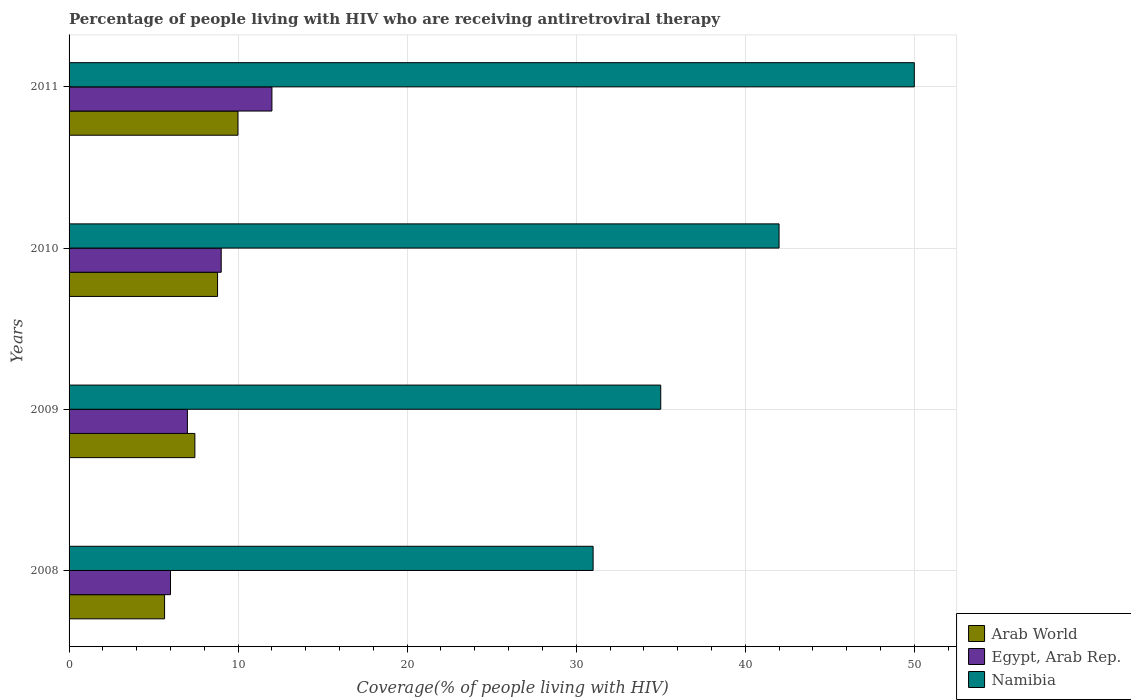In how many cases, is the number of bars for a given year not equal to the number of legend labels?
Ensure brevity in your answer.  0. What is the percentage of the HIV infected people who are receiving antiretroviral therapy in Egypt, Arab Rep. in 2010?
Keep it short and to the point. 9. Across all years, what is the maximum percentage of the HIV infected people who are receiving antiretroviral therapy in Arab World?
Make the answer very short. 9.99. What is the total percentage of the HIV infected people who are receiving antiretroviral therapy in Arab World in the graph?
Ensure brevity in your answer.  31.87. What is the difference between the percentage of the HIV infected people who are receiving antiretroviral therapy in Arab World in 2008 and that in 2011?
Make the answer very short. -4.34. What is the difference between the percentage of the HIV infected people who are receiving antiretroviral therapy in Namibia in 2010 and the percentage of the HIV infected people who are receiving antiretroviral therapy in Egypt, Arab Rep. in 2009?
Your response must be concise. 35. What is the average percentage of the HIV infected people who are receiving antiretroviral therapy in Namibia per year?
Make the answer very short. 39.5. In the year 2009, what is the difference between the percentage of the HIV infected people who are receiving antiretroviral therapy in Egypt, Arab Rep. and percentage of the HIV infected people who are receiving antiretroviral therapy in Namibia?
Ensure brevity in your answer.  -28. In how many years, is the percentage of the HIV infected people who are receiving antiretroviral therapy in Arab World greater than 34 %?
Keep it short and to the point. 0. What is the ratio of the percentage of the HIV infected people who are receiving antiretroviral therapy in Egypt, Arab Rep. in 2009 to that in 2011?
Provide a short and direct response. 0.58. Is the percentage of the HIV infected people who are receiving antiretroviral therapy in Namibia in 2008 less than that in 2010?
Your response must be concise. Yes. What is the difference between the highest and the lowest percentage of the HIV infected people who are receiving antiretroviral therapy in Namibia?
Provide a short and direct response. 19. In how many years, is the percentage of the HIV infected people who are receiving antiretroviral therapy in Arab World greater than the average percentage of the HIV infected people who are receiving antiretroviral therapy in Arab World taken over all years?
Provide a succinct answer. 2. Is the sum of the percentage of the HIV infected people who are receiving antiretroviral therapy in Egypt, Arab Rep. in 2008 and 2009 greater than the maximum percentage of the HIV infected people who are receiving antiretroviral therapy in Arab World across all years?
Your answer should be very brief. Yes. What does the 2nd bar from the top in 2010 represents?
Ensure brevity in your answer.  Egypt, Arab Rep. What does the 1st bar from the bottom in 2009 represents?
Your answer should be compact. Arab World. How many years are there in the graph?
Your response must be concise. 4. What is the difference between two consecutive major ticks on the X-axis?
Your answer should be compact. 10. Does the graph contain grids?
Your answer should be very brief. Yes. Where does the legend appear in the graph?
Give a very brief answer. Bottom right. What is the title of the graph?
Offer a very short reply. Percentage of people living with HIV who are receiving antiretroviral therapy. What is the label or title of the X-axis?
Keep it short and to the point. Coverage(% of people living with HIV). What is the label or title of the Y-axis?
Provide a succinct answer. Years. What is the Coverage(% of people living with HIV) in Arab World in 2008?
Provide a succinct answer. 5.65. What is the Coverage(% of people living with HIV) of Arab World in 2009?
Give a very brief answer. 7.44. What is the Coverage(% of people living with HIV) in Namibia in 2009?
Provide a short and direct response. 35. What is the Coverage(% of people living with HIV) in Arab World in 2010?
Your answer should be compact. 8.78. What is the Coverage(% of people living with HIV) in Arab World in 2011?
Keep it short and to the point. 9.99. Across all years, what is the maximum Coverage(% of people living with HIV) in Arab World?
Provide a short and direct response. 9.99. Across all years, what is the maximum Coverage(% of people living with HIV) in Namibia?
Make the answer very short. 50. Across all years, what is the minimum Coverage(% of people living with HIV) of Arab World?
Provide a succinct answer. 5.65. Across all years, what is the minimum Coverage(% of people living with HIV) of Egypt, Arab Rep.?
Your answer should be compact. 6. Across all years, what is the minimum Coverage(% of people living with HIV) in Namibia?
Provide a short and direct response. 31. What is the total Coverage(% of people living with HIV) of Arab World in the graph?
Your answer should be compact. 31.87. What is the total Coverage(% of people living with HIV) in Egypt, Arab Rep. in the graph?
Your answer should be very brief. 34. What is the total Coverage(% of people living with HIV) of Namibia in the graph?
Make the answer very short. 158. What is the difference between the Coverage(% of people living with HIV) of Arab World in 2008 and that in 2009?
Offer a terse response. -1.79. What is the difference between the Coverage(% of people living with HIV) in Arab World in 2008 and that in 2010?
Provide a succinct answer. -3.13. What is the difference between the Coverage(% of people living with HIV) of Egypt, Arab Rep. in 2008 and that in 2010?
Make the answer very short. -3. What is the difference between the Coverage(% of people living with HIV) of Arab World in 2008 and that in 2011?
Give a very brief answer. -4.34. What is the difference between the Coverage(% of people living with HIV) of Namibia in 2008 and that in 2011?
Provide a succinct answer. -19. What is the difference between the Coverage(% of people living with HIV) of Arab World in 2009 and that in 2010?
Make the answer very short. -1.34. What is the difference between the Coverage(% of people living with HIV) of Egypt, Arab Rep. in 2009 and that in 2010?
Your answer should be very brief. -2. What is the difference between the Coverage(% of people living with HIV) of Arab World in 2009 and that in 2011?
Offer a terse response. -2.55. What is the difference between the Coverage(% of people living with HIV) of Arab World in 2010 and that in 2011?
Give a very brief answer. -1.21. What is the difference between the Coverage(% of people living with HIV) of Egypt, Arab Rep. in 2010 and that in 2011?
Give a very brief answer. -3. What is the difference between the Coverage(% of people living with HIV) in Namibia in 2010 and that in 2011?
Offer a very short reply. -8. What is the difference between the Coverage(% of people living with HIV) of Arab World in 2008 and the Coverage(% of people living with HIV) of Egypt, Arab Rep. in 2009?
Your answer should be very brief. -1.35. What is the difference between the Coverage(% of people living with HIV) in Arab World in 2008 and the Coverage(% of people living with HIV) in Namibia in 2009?
Give a very brief answer. -29.35. What is the difference between the Coverage(% of people living with HIV) of Egypt, Arab Rep. in 2008 and the Coverage(% of people living with HIV) of Namibia in 2009?
Provide a succinct answer. -29. What is the difference between the Coverage(% of people living with HIV) in Arab World in 2008 and the Coverage(% of people living with HIV) in Egypt, Arab Rep. in 2010?
Your response must be concise. -3.35. What is the difference between the Coverage(% of people living with HIV) of Arab World in 2008 and the Coverage(% of people living with HIV) of Namibia in 2010?
Give a very brief answer. -36.35. What is the difference between the Coverage(% of people living with HIV) in Egypt, Arab Rep. in 2008 and the Coverage(% of people living with HIV) in Namibia in 2010?
Offer a very short reply. -36. What is the difference between the Coverage(% of people living with HIV) of Arab World in 2008 and the Coverage(% of people living with HIV) of Egypt, Arab Rep. in 2011?
Make the answer very short. -6.35. What is the difference between the Coverage(% of people living with HIV) of Arab World in 2008 and the Coverage(% of people living with HIV) of Namibia in 2011?
Provide a succinct answer. -44.35. What is the difference between the Coverage(% of people living with HIV) in Egypt, Arab Rep. in 2008 and the Coverage(% of people living with HIV) in Namibia in 2011?
Offer a very short reply. -44. What is the difference between the Coverage(% of people living with HIV) in Arab World in 2009 and the Coverage(% of people living with HIV) in Egypt, Arab Rep. in 2010?
Offer a terse response. -1.56. What is the difference between the Coverage(% of people living with HIV) of Arab World in 2009 and the Coverage(% of people living with HIV) of Namibia in 2010?
Offer a terse response. -34.56. What is the difference between the Coverage(% of people living with HIV) in Egypt, Arab Rep. in 2009 and the Coverage(% of people living with HIV) in Namibia in 2010?
Ensure brevity in your answer.  -35. What is the difference between the Coverage(% of people living with HIV) of Arab World in 2009 and the Coverage(% of people living with HIV) of Egypt, Arab Rep. in 2011?
Your answer should be very brief. -4.56. What is the difference between the Coverage(% of people living with HIV) in Arab World in 2009 and the Coverage(% of people living with HIV) in Namibia in 2011?
Provide a short and direct response. -42.56. What is the difference between the Coverage(% of people living with HIV) of Egypt, Arab Rep. in 2009 and the Coverage(% of people living with HIV) of Namibia in 2011?
Ensure brevity in your answer.  -43. What is the difference between the Coverage(% of people living with HIV) in Arab World in 2010 and the Coverage(% of people living with HIV) in Egypt, Arab Rep. in 2011?
Your answer should be compact. -3.22. What is the difference between the Coverage(% of people living with HIV) of Arab World in 2010 and the Coverage(% of people living with HIV) of Namibia in 2011?
Offer a very short reply. -41.22. What is the difference between the Coverage(% of people living with HIV) of Egypt, Arab Rep. in 2010 and the Coverage(% of people living with HIV) of Namibia in 2011?
Keep it short and to the point. -41. What is the average Coverage(% of people living with HIV) of Arab World per year?
Your response must be concise. 7.97. What is the average Coverage(% of people living with HIV) of Namibia per year?
Your answer should be compact. 39.5. In the year 2008, what is the difference between the Coverage(% of people living with HIV) of Arab World and Coverage(% of people living with HIV) of Egypt, Arab Rep.?
Provide a succinct answer. -0.35. In the year 2008, what is the difference between the Coverage(% of people living with HIV) of Arab World and Coverage(% of people living with HIV) of Namibia?
Offer a very short reply. -25.35. In the year 2009, what is the difference between the Coverage(% of people living with HIV) in Arab World and Coverage(% of people living with HIV) in Egypt, Arab Rep.?
Offer a terse response. 0.44. In the year 2009, what is the difference between the Coverage(% of people living with HIV) of Arab World and Coverage(% of people living with HIV) of Namibia?
Offer a terse response. -27.56. In the year 2009, what is the difference between the Coverage(% of people living with HIV) of Egypt, Arab Rep. and Coverage(% of people living with HIV) of Namibia?
Your answer should be very brief. -28. In the year 2010, what is the difference between the Coverage(% of people living with HIV) of Arab World and Coverage(% of people living with HIV) of Egypt, Arab Rep.?
Your response must be concise. -0.22. In the year 2010, what is the difference between the Coverage(% of people living with HIV) of Arab World and Coverage(% of people living with HIV) of Namibia?
Offer a terse response. -33.22. In the year 2010, what is the difference between the Coverage(% of people living with HIV) of Egypt, Arab Rep. and Coverage(% of people living with HIV) of Namibia?
Your response must be concise. -33. In the year 2011, what is the difference between the Coverage(% of people living with HIV) in Arab World and Coverage(% of people living with HIV) in Egypt, Arab Rep.?
Provide a short and direct response. -2.01. In the year 2011, what is the difference between the Coverage(% of people living with HIV) in Arab World and Coverage(% of people living with HIV) in Namibia?
Offer a very short reply. -40.01. In the year 2011, what is the difference between the Coverage(% of people living with HIV) of Egypt, Arab Rep. and Coverage(% of people living with HIV) of Namibia?
Give a very brief answer. -38. What is the ratio of the Coverage(% of people living with HIV) of Arab World in 2008 to that in 2009?
Give a very brief answer. 0.76. What is the ratio of the Coverage(% of people living with HIV) of Egypt, Arab Rep. in 2008 to that in 2009?
Ensure brevity in your answer.  0.86. What is the ratio of the Coverage(% of people living with HIV) of Namibia in 2008 to that in 2009?
Your response must be concise. 0.89. What is the ratio of the Coverage(% of people living with HIV) of Arab World in 2008 to that in 2010?
Provide a short and direct response. 0.64. What is the ratio of the Coverage(% of people living with HIV) of Namibia in 2008 to that in 2010?
Your answer should be compact. 0.74. What is the ratio of the Coverage(% of people living with HIV) in Arab World in 2008 to that in 2011?
Provide a succinct answer. 0.57. What is the ratio of the Coverage(% of people living with HIV) in Egypt, Arab Rep. in 2008 to that in 2011?
Give a very brief answer. 0.5. What is the ratio of the Coverage(% of people living with HIV) of Namibia in 2008 to that in 2011?
Ensure brevity in your answer.  0.62. What is the ratio of the Coverage(% of people living with HIV) in Arab World in 2009 to that in 2010?
Provide a short and direct response. 0.85. What is the ratio of the Coverage(% of people living with HIV) in Arab World in 2009 to that in 2011?
Provide a succinct answer. 0.74. What is the ratio of the Coverage(% of people living with HIV) in Egypt, Arab Rep. in 2009 to that in 2011?
Provide a short and direct response. 0.58. What is the ratio of the Coverage(% of people living with HIV) of Arab World in 2010 to that in 2011?
Your response must be concise. 0.88. What is the ratio of the Coverage(% of people living with HIV) in Egypt, Arab Rep. in 2010 to that in 2011?
Offer a very short reply. 0.75. What is the ratio of the Coverage(% of people living with HIV) in Namibia in 2010 to that in 2011?
Offer a very short reply. 0.84. What is the difference between the highest and the second highest Coverage(% of people living with HIV) in Arab World?
Your answer should be very brief. 1.21. What is the difference between the highest and the second highest Coverage(% of people living with HIV) in Egypt, Arab Rep.?
Provide a short and direct response. 3. What is the difference between the highest and the second highest Coverage(% of people living with HIV) in Namibia?
Keep it short and to the point. 8. What is the difference between the highest and the lowest Coverage(% of people living with HIV) in Arab World?
Your answer should be very brief. 4.34. What is the difference between the highest and the lowest Coverage(% of people living with HIV) in Namibia?
Make the answer very short. 19. 